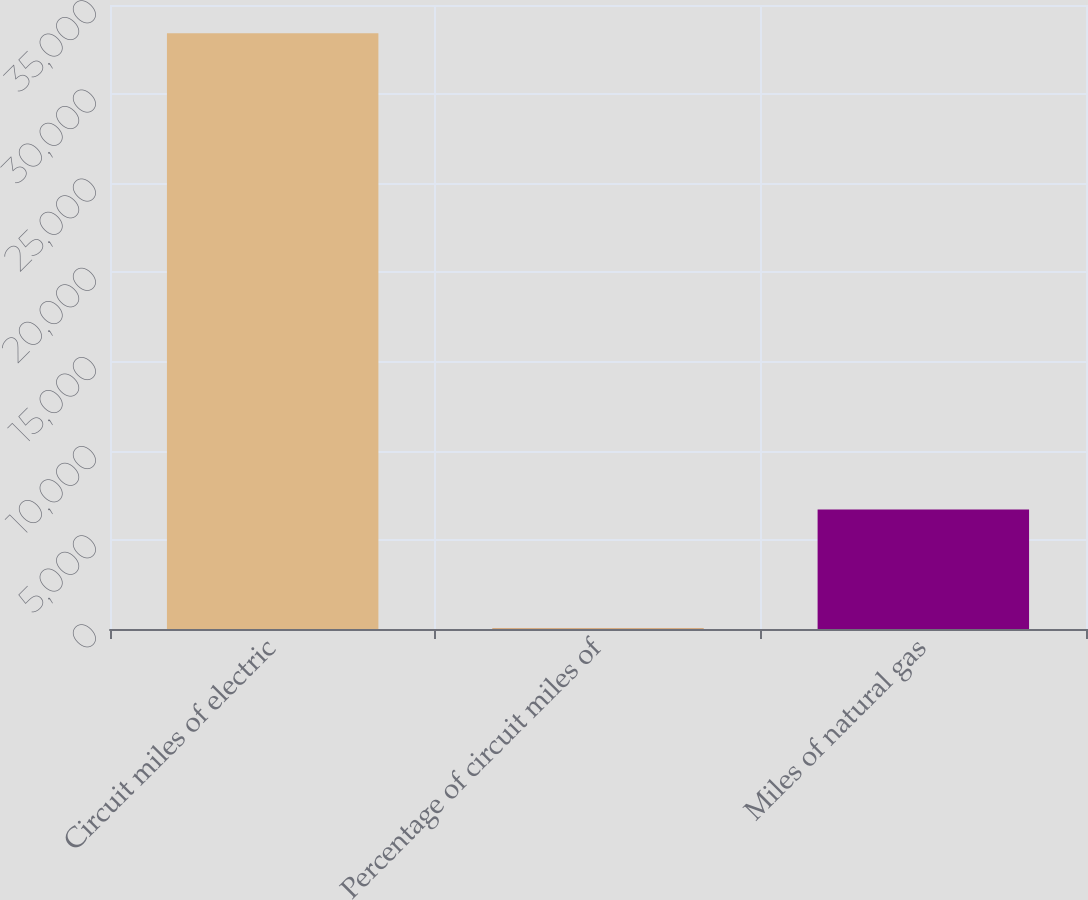<chart> <loc_0><loc_0><loc_500><loc_500><bar_chart><fcel>Circuit miles of electric<fcel>Percentage of circuit miles of<fcel>Miles of natural gas<nl><fcel>33414<fcel>23<fcel>6701.2<nl></chart> 